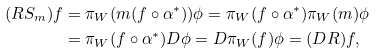Convert formula to latex. <formula><loc_0><loc_0><loc_500><loc_500>( R S _ { m } ) f & = \pi _ { W } ( m ( f \circ \alpha ^ { * } ) ) \phi = \pi _ { W } ( f \circ \alpha ^ { * } ) \pi _ { W } ( m ) \phi \\ & = \pi _ { W } ( f \circ \alpha ^ { * } ) D \phi = D \pi _ { W } ( f ) \phi = ( D R ) f ,</formula> 